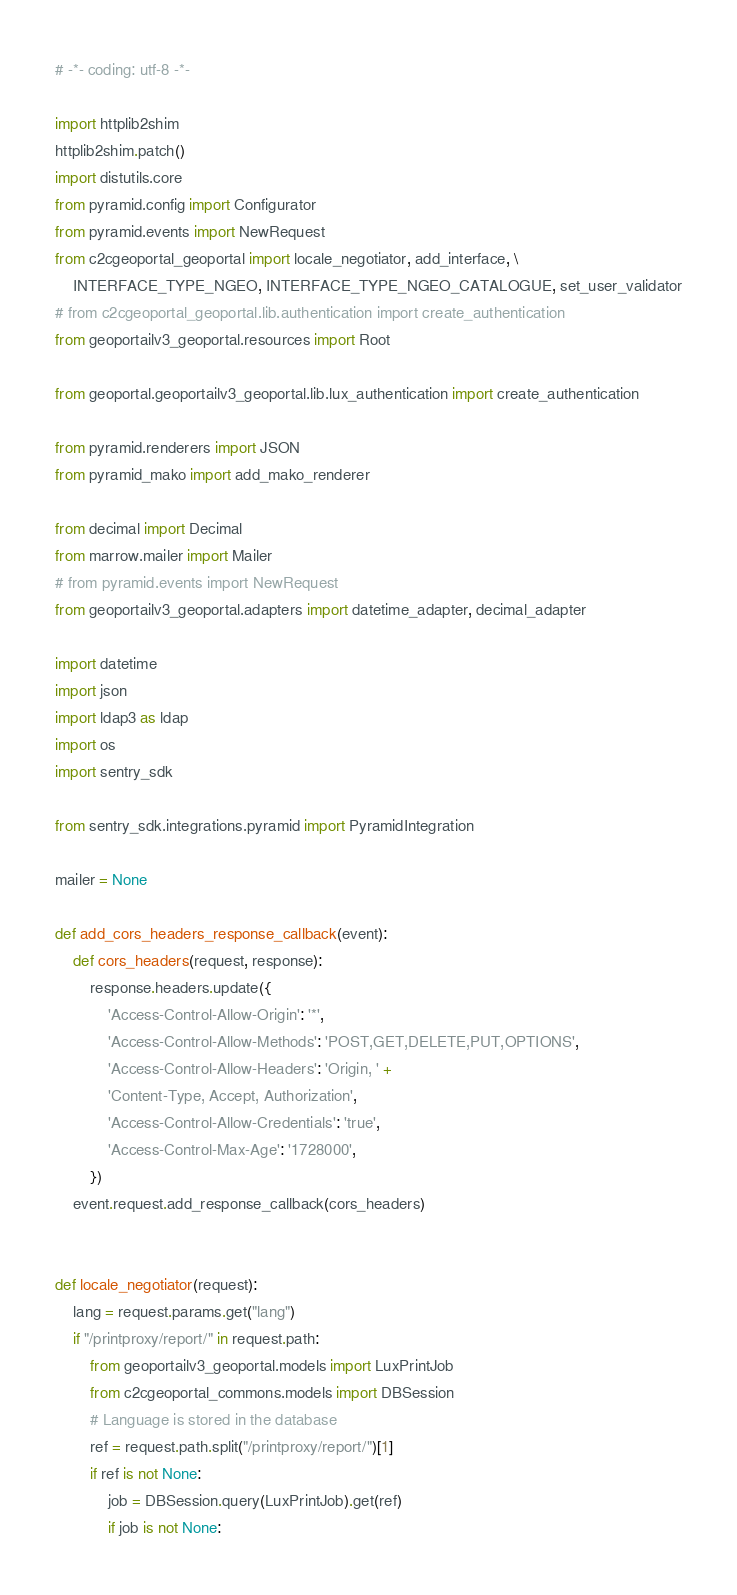Convert code to text. <code><loc_0><loc_0><loc_500><loc_500><_Python_># -*- coding: utf-8 -*-

import httplib2shim
httplib2shim.patch()
import distutils.core
from pyramid.config import Configurator
from pyramid.events import NewRequest
from c2cgeoportal_geoportal import locale_negotiator, add_interface, \
    INTERFACE_TYPE_NGEO, INTERFACE_TYPE_NGEO_CATALOGUE, set_user_validator
# from c2cgeoportal_geoportal.lib.authentication import create_authentication
from geoportailv3_geoportal.resources import Root

from geoportal.geoportailv3_geoportal.lib.lux_authentication import create_authentication

from pyramid.renderers import JSON
from pyramid_mako import add_mako_renderer

from decimal import Decimal
from marrow.mailer import Mailer
# from pyramid.events import NewRequest
from geoportailv3_geoportal.adapters import datetime_adapter, decimal_adapter

import datetime
import json
import ldap3 as ldap
import os
import sentry_sdk

from sentry_sdk.integrations.pyramid import PyramidIntegration

mailer = None

def add_cors_headers_response_callback(event):
    def cors_headers(request, response):
        response.headers.update({
            'Access-Control-Allow-Origin': '*',
            'Access-Control-Allow-Methods': 'POST,GET,DELETE,PUT,OPTIONS',
            'Access-Control-Allow-Headers': 'Origin, ' +
            'Content-Type, Accept, Authorization',
            'Access-Control-Allow-Credentials': 'true',
            'Access-Control-Max-Age': '1728000',
        })
    event.request.add_response_callback(cors_headers)


def locale_negotiator(request):
    lang = request.params.get("lang")
    if "/printproxy/report/" in request.path:
        from geoportailv3_geoportal.models import LuxPrintJob
        from c2cgeoportal_commons.models import DBSession
        # Language is stored in the database
        ref = request.path.split("/printproxy/report/")[1]
        if ref is not None:
            job = DBSession.query(LuxPrintJob).get(ref)
            if job is not None:</code> 